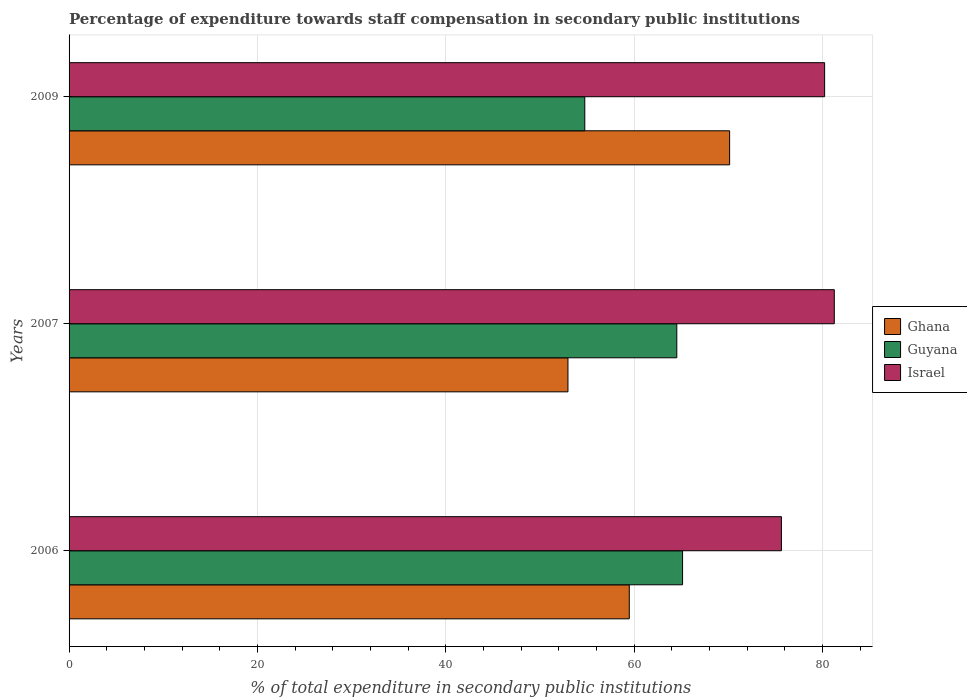How many different coloured bars are there?
Give a very brief answer. 3. Are the number of bars per tick equal to the number of legend labels?
Ensure brevity in your answer.  Yes. How many bars are there on the 1st tick from the top?
Keep it short and to the point. 3. How many bars are there on the 1st tick from the bottom?
Give a very brief answer. 3. What is the percentage of expenditure towards staff compensation in Guyana in 2007?
Your response must be concise. 64.52. Across all years, what is the maximum percentage of expenditure towards staff compensation in Ghana?
Make the answer very short. 70.13. Across all years, what is the minimum percentage of expenditure towards staff compensation in Israel?
Give a very brief answer. 75.63. In which year was the percentage of expenditure towards staff compensation in Guyana maximum?
Your response must be concise. 2006. In which year was the percentage of expenditure towards staff compensation in Ghana minimum?
Keep it short and to the point. 2007. What is the total percentage of expenditure towards staff compensation in Israel in the graph?
Your answer should be compact. 237.09. What is the difference between the percentage of expenditure towards staff compensation in Ghana in 2006 and that in 2009?
Your answer should be very brief. -10.65. What is the difference between the percentage of expenditure towards staff compensation in Israel in 2009 and the percentage of expenditure towards staff compensation in Guyana in 2007?
Provide a succinct answer. 15.7. What is the average percentage of expenditure towards staff compensation in Guyana per year?
Make the answer very short. 61.47. In the year 2007, what is the difference between the percentage of expenditure towards staff compensation in Guyana and percentage of expenditure towards staff compensation in Israel?
Offer a very short reply. -16.72. What is the ratio of the percentage of expenditure towards staff compensation in Ghana in 2006 to that in 2007?
Your response must be concise. 1.12. Is the percentage of expenditure towards staff compensation in Israel in 2006 less than that in 2009?
Ensure brevity in your answer.  Yes. Is the difference between the percentage of expenditure towards staff compensation in Guyana in 2006 and 2009 greater than the difference between the percentage of expenditure towards staff compensation in Israel in 2006 and 2009?
Offer a terse response. Yes. What is the difference between the highest and the second highest percentage of expenditure towards staff compensation in Ghana?
Provide a short and direct response. 10.65. What is the difference between the highest and the lowest percentage of expenditure towards staff compensation in Ghana?
Offer a very short reply. 17.17. In how many years, is the percentage of expenditure towards staff compensation in Ghana greater than the average percentage of expenditure towards staff compensation in Ghana taken over all years?
Your answer should be compact. 1. Is the sum of the percentage of expenditure towards staff compensation in Guyana in 2007 and 2009 greater than the maximum percentage of expenditure towards staff compensation in Israel across all years?
Provide a short and direct response. Yes. What does the 2nd bar from the top in 2009 represents?
Your response must be concise. Guyana. What does the 1st bar from the bottom in 2009 represents?
Offer a very short reply. Ghana. Is it the case that in every year, the sum of the percentage of expenditure towards staff compensation in Israel and percentage of expenditure towards staff compensation in Guyana is greater than the percentage of expenditure towards staff compensation in Ghana?
Your response must be concise. Yes. Are all the bars in the graph horizontal?
Give a very brief answer. Yes. How many years are there in the graph?
Offer a very short reply. 3. Are the values on the major ticks of X-axis written in scientific E-notation?
Provide a succinct answer. No. Does the graph contain any zero values?
Keep it short and to the point. No. Where does the legend appear in the graph?
Offer a very short reply. Center right. How are the legend labels stacked?
Your answer should be compact. Vertical. What is the title of the graph?
Your answer should be compact. Percentage of expenditure towards staff compensation in secondary public institutions. Does "Portugal" appear as one of the legend labels in the graph?
Your response must be concise. No. What is the label or title of the X-axis?
Keep it short and to the point. % of total expenditure in secondary public institutions. What is the % of total expenditure in secondary public institutions of Ghana in 2006?
Make the answer very short. 59.48. What is the % of total expenditure in secondary public institutions of Guyana in 2006?
Your answer should be compact. 65.13. What is the % of total expenditure in secondary public institutions of Israel in 2006?
Your answer should be very brief. 75.63. What is the % of total expenditure in secondary public institutions of Ghana in 2007?
Give a very brief answer. 52.97. What is the % of total expenditure in secondary public institutions of Guyana in 2007?
Keep it short and to the point. 64.52. What is the % of total expenditure in secondary public institutions in Israel in 2007?
Offer a very short reply. 81.24. What is the % of total expenditure in secondary public institutions of Ghana in 2009?
Your answer should be very brief. 70.13. What is the % of total expenditure in secondary public institutions in Guyana in 2009?
Your answer should be compact. 54.75. What is the % of total expenditure in secondary public institutions in Israel in 2009?
Offer a very short reply. 80.22. Across all years, what is the maximum % of total expenditure in secondary public institutions in Ghana?
Provide a succinct answer. 70.13. Across all years, what is the maximum % of total expenditure in secondary public institutions in Guyana?
Your response must be concise. 65.13. Across all years, what is the maximum % of total expenditure in secondary public institutions of Israel?
Provide a short and direct response. 81.24. Across all years, what is the minimum % of total expenditure in secondary public institutions of Ghana?
Offer a very short reply. 52.97. Across all years, what is the minimum % of total expenditure in secondary public institutions of Guyana?
Make the answer very short. 54.75. Across all years, what is the minimum % of total expenditure in secondary public institutions of Israel?
Your response must be concise. 75.63. What is the total % of total expenditure in secondary public institutions in Ghana in the graph?
Give a very brief answer. 182.57. What is the total % of total expenditure in secondary public institutions of Guyana in the graph?
Your answer should be very brief. 184.41. What is the total % of total expenditure in secondary public institutions in Israel in the graph?
Give a very brief answer. 237.09. What is the difference between the % of total expenditure in secondary public institutions of Ghana in 2006 and that in 2007?
Your answer should be compact. 6.51. What is the difference between the % of total expenditure in secondary public institutions in Guyana in 2006 and that in 2007?
Your answer should be very brief. 0.61. What is the difference between the % of total expenditure in secondary public institutions of Israel in 2006 and that in 2007?
Keep it short and to the point. -5.61. What is the difference between the % of total expenditure in secondary public institutions in Ghana in 2006 and that in 2009?
Make the answer very short. -10.65. What is the difference between the % of total expenditure in secondary public institutions in Guyana in 2006 and that in 2009?
Your response must be concise. 10.38. What is the difference between the % of total expenditure in secondary public institutions of Israel in 2006 and that in 2009?
Ensure brevity in your answer.  -4.59. What is the difference between the % of total expenditure in secondary public institutions of Ghana in 2007 and that in 2009?
Make the answer very short. -17.17. What is the difference between the % of total expenditure in secondary public institutions of Guyana in 2007 and that in 2009?
Ensure brevity in your answer.  9.77. What is the difference between the % of total expenditure in secondary public institutions in Israel in 2007 and that in 2009?
Provide a short and direct response. 1.03. What is the difference between the % of total expenditure in secondary public institutions of Ghana in 2006 and the % of total expenditure in secondary public institutions of Guyana in 2007?
Provide a short and direct response. -5.04. What is the difference between the % of total expenditure in secondary public institutions of Ghana in 2006 and the % of total expenditure in secondary public institutions of Israel in 2007?
Keep it short and to the point. -21.77. What is the difference between the % of total expenditure in secondary public institutions of Guyana in 2006 and the % of total expenditure in secondary public institutions of Israel in 2007?
Offer a terse response. -16.11. What is the difference between the % of total expenditure in secondary public institutions in Ghana in 2006 and the % of total expenditure in secondary public institutions in Guyana in 2009?
Make the answer very short. 4.72. What is the difference between the % of total expenditure in secondary public institutions in Ghana in 2006 and the % of total expenditure in secondary public institutions in Israel in 2009?
Ensure brevity in your answer.  -20.74. What is the difference between the % of total expenditure in secondary public institutions of Guyana in 2006 and the % of total expenditure in secondary public institutions of Israel in 2009?
Offer a very short reply. -15.08. What is the difference between the % of total expenditure in secondary public institutions of Ghana in 2007 and the % of total expenditure in secondary public institutions of Guyana in 2009?
Offer a very short reply. -1.79. What is the difference between the % of total expenditure in secondary public institutions of Ghana in 2007 and the % of total expenditure in secondary public institutions of Israel in 2009?
Your response must be concise. -27.25. What is the difference between the % of total expenditure in secondary public institutions of Guyana in 2007 and the % of total expenditure in secondary public institutions of Israel in 2009?
Provide a short and direct response. -15.7. What is the average % of total expenditure in secondary public institutions of Ghana per year?
Your answer should be compact. 60.86. What is the average % of total expenditure in secondary public institutions of Guyana per year?
Your answer should be very brief. 61.47. What is the average % of total expenditure in secondary public institutions in Israel per year?
Your response must be concise. 79.03. In the year 2006, what is the difference between the % of total expenditure in secondary public institutions in Ghana and % of total expenditure in secondary public institutions in Guyana?
Offer a terse response. -5.66. In the year 2006, what is the difference between the % of total expenditure in secondary public institutions of Ghana and % of total expenditure in secondary public institutions of Israel?
Your answer should be compact. -16.15. In the year 2006, what is the difference between the % of total expenditure in secondary public institutions of Guyana and % of total expenditure in secondary public institutions of Israel?
Make the answer very short. -10.5. In the year 2007, what is the difference between the % of total expenditure in secondary public institutions in Ghana and % of total expenditure in secondary public institutions in Guyana?
Provide a succinct answer. -11.56. In the year 2007, what is the difference between the % of total expenditure in secondary public institutions of Ghana and % of total expenditure in secondary public institutions of Israel?
Keep it short and to the point. -28.28. In the year 2007, what is the difference between the % of total expenditure in secondary public institutions of Guyana and % of total expenditure in secondary public institutions of Israel?
Provide a short and direct response. -16.72. In the year 2009, what is the difference between the % of total expenditure in secondary public institutions in Ghana and % of total expenditure in secondary public institutions in Guyana?
Offer a terse response. 15.38. In the year 2009, what is the difference between the % of total expenditure in secondary public institutions of Ghana and % of total expenditure in secondary public institutions of Israel?
Offer a very short reply. -10.09. In the year 2009, what is the difference between the % of total expenditure in secondary public institutions of Guyana and % of total expenditure in secondary public institutions of Israel?
Your response must be concise. -25.46. What is the ratio of the % of total expenditure in secondary public institutions of Ghana in 2006 to that in 2007?
Your response must be concise. 1.12. What is the ratio of the % of total expenditure in secondary public institutions in Guyana in 2006 to that in 2007?
Provide a short and direct response. 1.01. What is the ratio of the % of total expenditure in secondary public institutions in Israel in 2006 to that in 2007?
Your response must be concise. 0.93. What is the ratio of the % of total expenditure in secondary public institutions in Ghana in 2006 to that in 2009?
Keep it short and to the point. 0.85. What is the ratio of the % of total expenditure in secondary public institutions of Guyana in 2006 to that in 2009?
Give a very brief answer. 1.19. What is the ratio of the % of total expenditure in secondary public institutions of Israel in 2006 to that in 2009?
Your answer should be compact. 0.94. What is the ratio of the % of total expenditure in secondary public institutions in Ghana in 2007 to that in 2009?
Provide a succinct answer. 0.76. What is the ratio of the % of total expenditure in secondary public institutions in Guyana in 2007 to that in 2009?
Ensure brevity in your answer.  1.18. What is the ratio of the % of total expenditure in secondary public institutions in Israel in 2007 to that in 2009?
Provide a short and direct response. 1.01. What is the difference between the highest and the second highest % of total expenditure in secondary public institutions in Ghana?
Offer a terse response. 10.65. What is the difference between the highest and the second highest % of total expenditure in secondary public institutions in Guyana?
Your answer should be very brief. 0.61. What is the difference between the highest and the second highest % of total expenditure in secondary public institutions in Israel?
Ensure brevity in your answer.  1.03. What is the difference between the highest and the lowest % of total expenditure in secondary public institutions in Ghana?
Keep it short and to the point. 17.17. What is the difference between the highest and the lowest % of total expenditure in secondary public institutions in Guyana?
Make the answer very short. 10.38. What is the difference between the highest and the lowest % of total expenditure in secondary public institutions in Israel?
Provide a short and direct response. 5.61. 